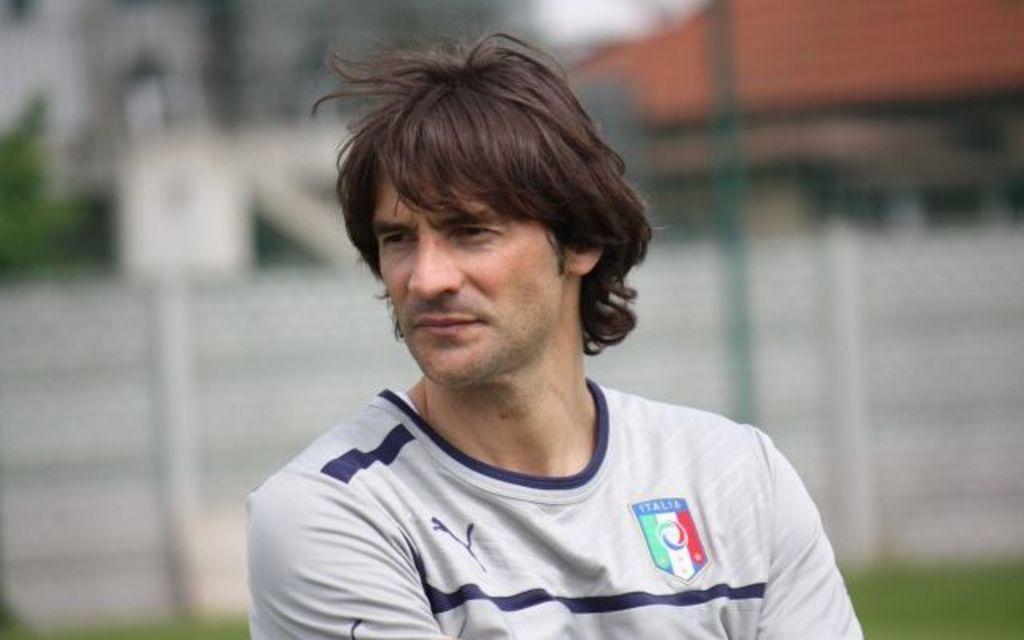What country does the man play for?
Offer a terse response. Italy. What is the name on the emblem on the man's shirt?
Make the answer very short. Italia. 